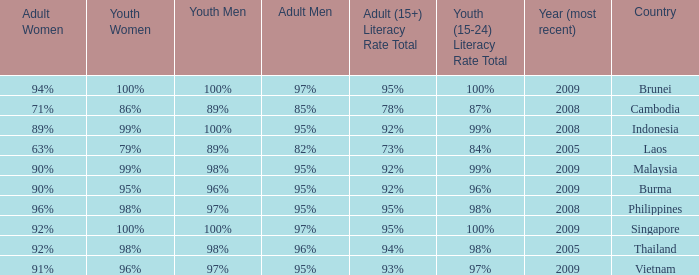Which country has a Youth (15-24) Literacy Rate Total of 100% and has an Adult Women Literacy rate of 92%? Singapore. 